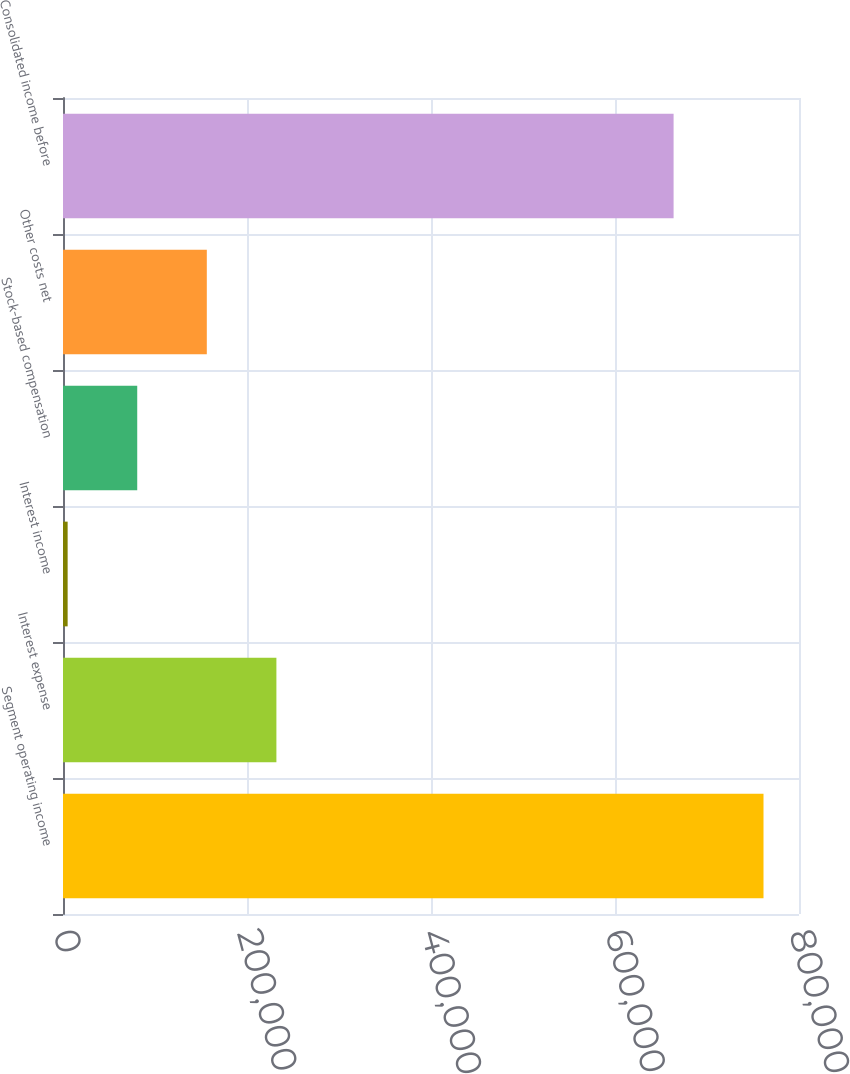Convert chart to OTSL. <chart><loc_0><loc_0><loc_500><loc_500><bar_chart><fcel>Segment operating income<fcel>Interest expense<fcel>Interest income<fcel>Stock-based compensation<fcel>Other costs net<fcel>Consolidated income before<nl><fcel>761418<fcel>231958<fcel>5046<fcel>80683.2<fcel>156320<fcel>663688<nl></chart> 